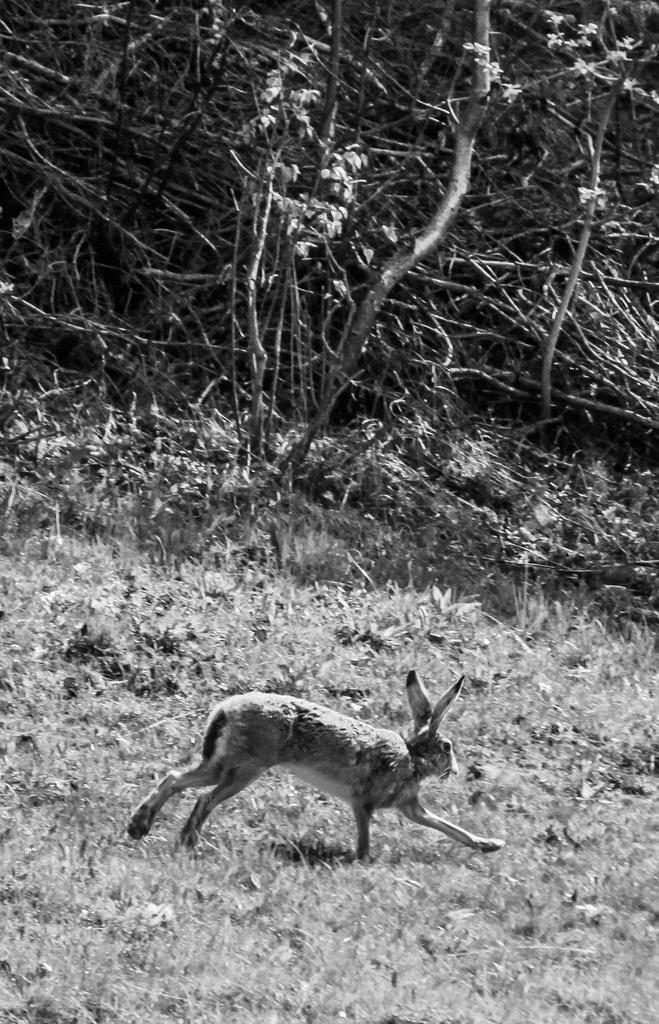What type of animal is in the image? The type of animal cannot be determined from the provided facts. Where is the animal located in the image? The animal is on the grass in the image. What can be seen in the background of the image? There are many trees in the background of the image. What is the color scheme of the image? The image is black and white. Is the animal holding an umbrella in the image? There is no umbrella present in the image. What does the image smell like? The image is a visual representation and does not have a smell. 